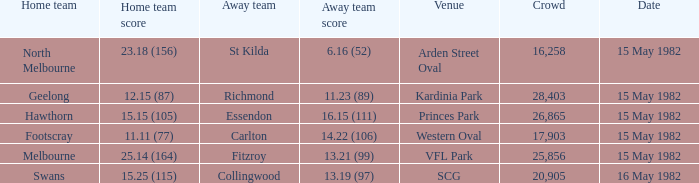In which match did the home team face an away team with a score of 13.19 (97)? Swans. 